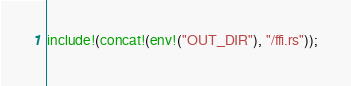Convert code to text. <code><loc_0><loc_0><loc_500><loc_500><_Rust_>include!(concat!(env!("OUT_DIR"), "/ffi.rs"));</code> 